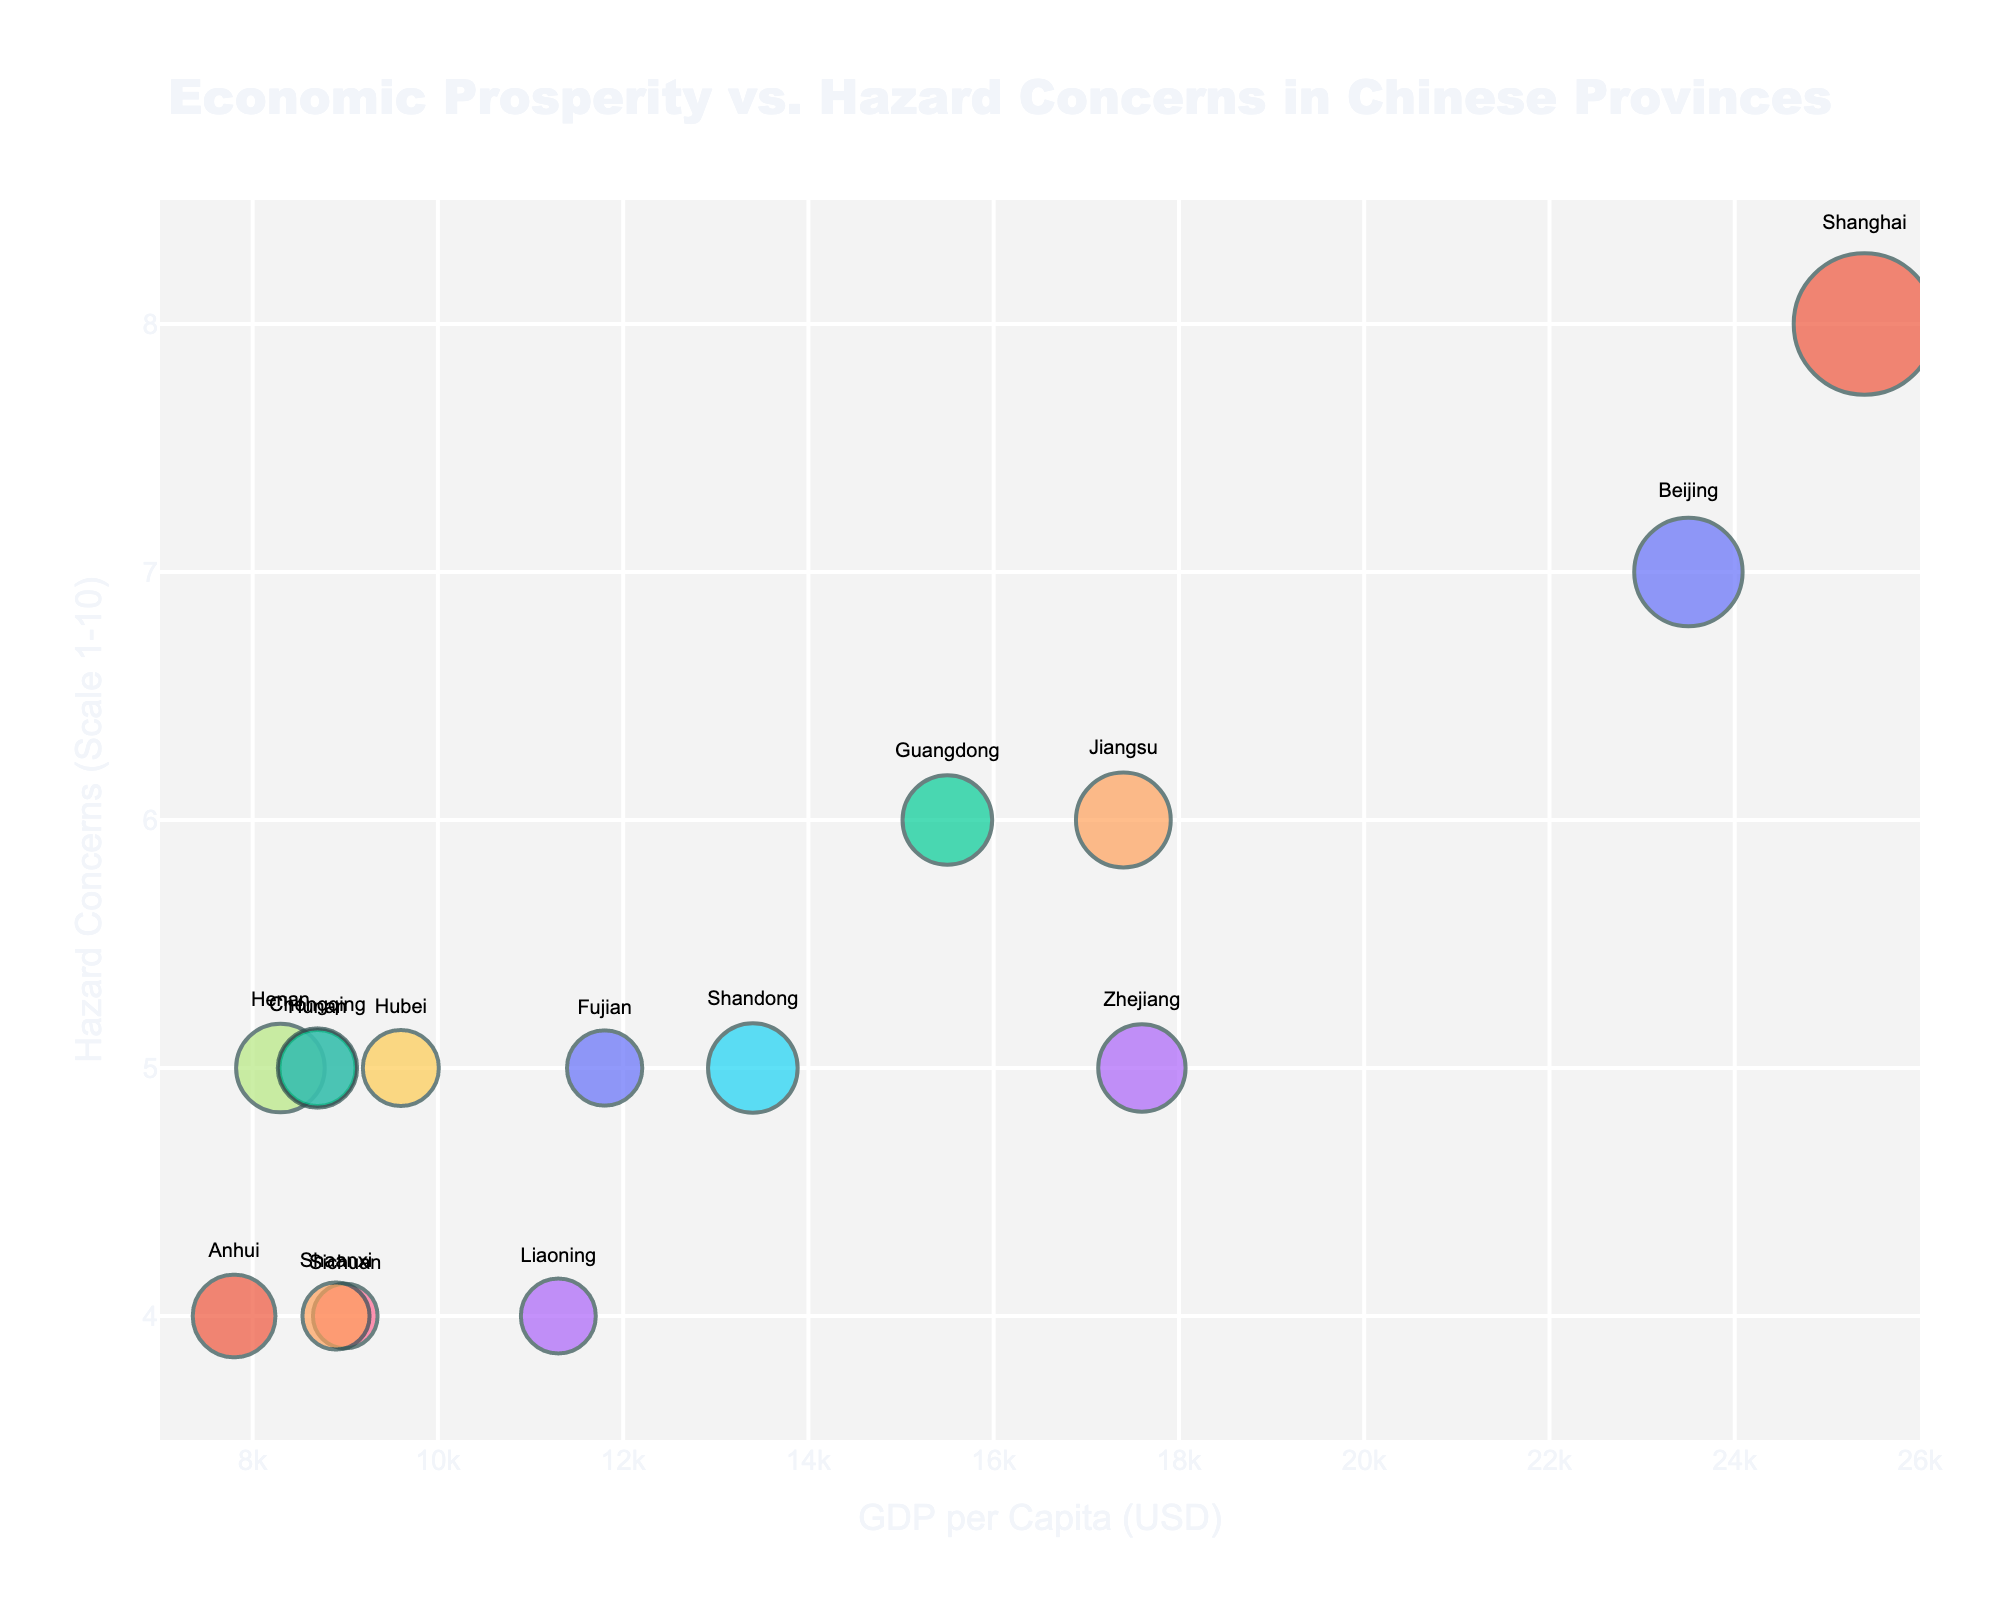What's the title of the figure? The title of the figure is at the top center, shown with larger and bold font.
Answer: Economic Prosperity vs. Hazard Concerns in Chinese Provinces What's the x-axis title? The x-axis title is shown at the bottom part of the figure, horizontally aligned.
Answer: GDP per Capita (USD) Which provinces have a population density higher than 600 people per sq km? Look for bubbles representing provinces with population density higher than 600 by hovering over or referring to labels.
Answer: Beijing, Shanghai, Guangdong, Jiangsu, Shandong Which province has the highest GDP per Capita and what is its hazard concern level? Find the bubble furthest to the right, as GDP per capita increases from left to right. The hazard concern level is the y-coordinate of this bubble.
Answer: Shanghai, 8 What is the relationship between GDP per Capita and Hazard Concerns based on the given data? Observe the overall trend in bubble positions: higher GDP per Capita tends to associate with higher hazard concern levels.
Answer: Positive correlation Compare the hazard concerns of the provinces with the highest and lowest GDP per capita. Identify the provinces with the highest and lowest GDP per Capita, then compare their y-coordinates which represent hazard concerns.
Answer: Shanghai (8) is the highest, and Henan (5) is the lowest Which province is most densely populated and what are its GDP per Capita and hazard concern level? Identify the largest bubble indicating the highest population density, then check its x and y coordinates.
Answer: Shanghai, 25400 USD, 8 Which provinces have hazard concerns below level 5? Look for bubbles positioned below the y-value of 5 on the chart.
Answer: Sichuan, Anhui, Liaoning, Shaanxi Calculate the average GDP per Capita of provinces with hazard concerns of level 5. Add up the GDP per Capita of all provinces with hazard concern level 5 (Zhejiang, Shandong, Hunan, Hubei, Fujian, Chongqing), then divide by the number of these provinces.
Answer: (17600 + 13400 + 8700 + 9600 + 11800 + 8700) / 6 = 11666.67 Which provinces show the lowest hazard concern level, and what are their GDP per Capita values? Find the bubbles positioned lowest on the y-axis, then check their x-coordinates for GDP per Capita.
Answer: Sichuan (9000), Anhui (7800), Liaoning (11300), Shaanxi (8900) 